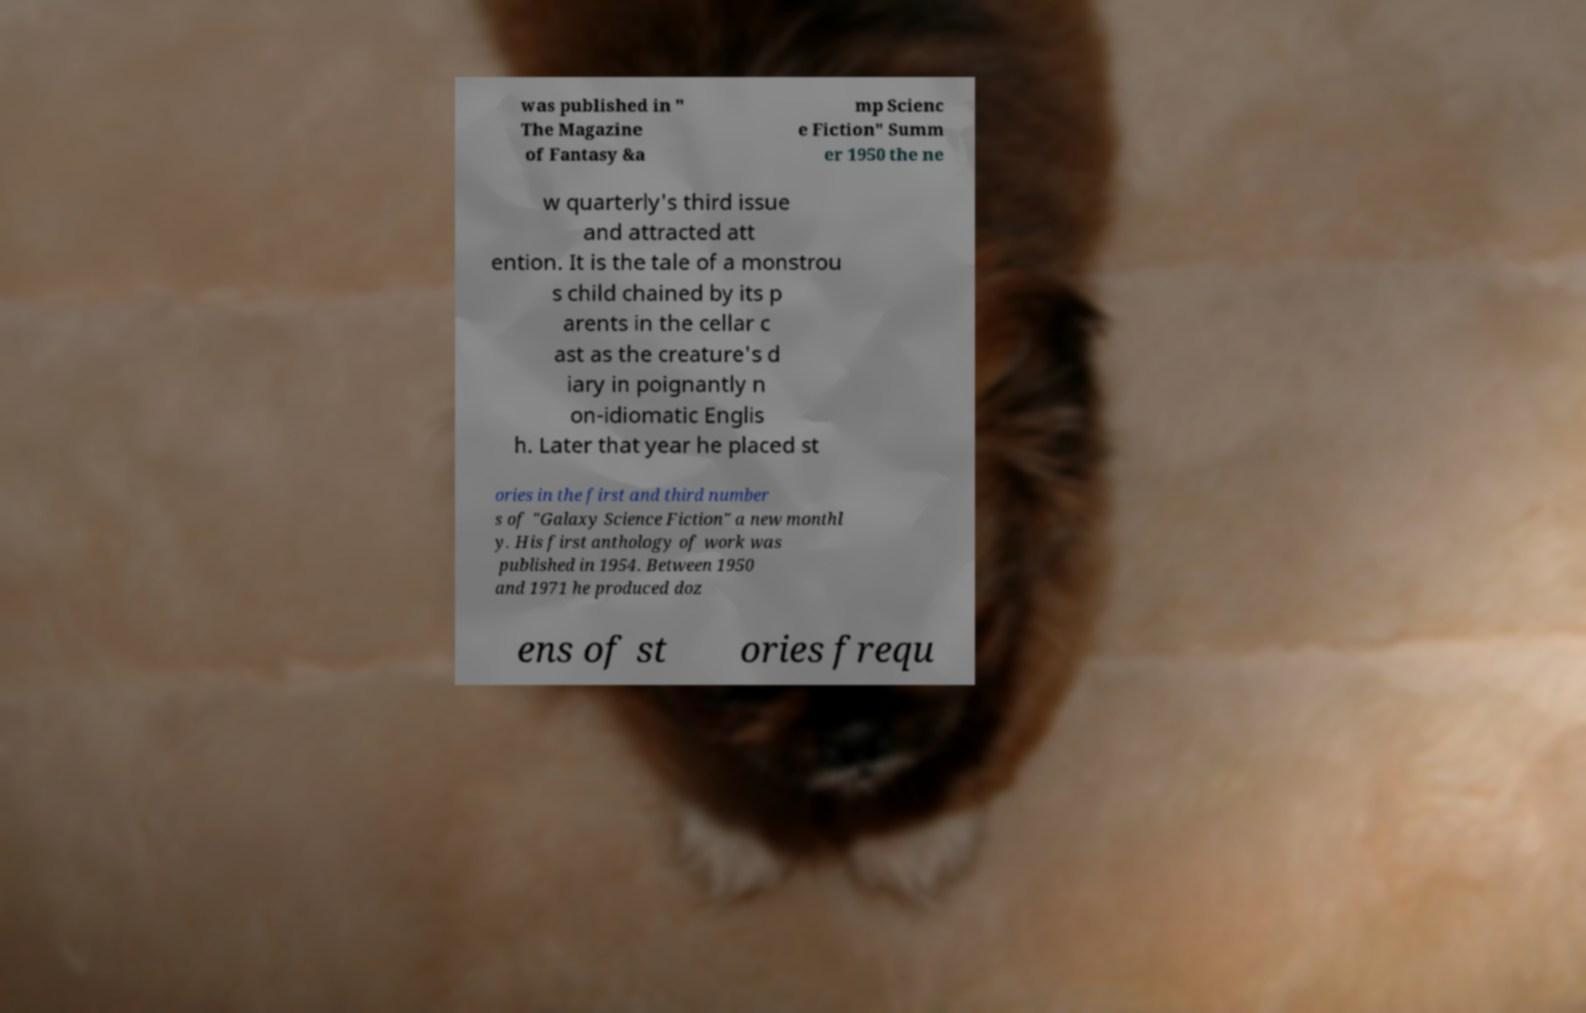Please read and relay the text visible in this image. What does it say? was published in " The Magazine of Fantasy &a mp Scienc e Fiction" Summ er 1950 the ne w quarterly's third issue and attracted att ention. It is the tale of a monstrou s child chained by its p arents in the cellar c ast as the creature's d iary in poignantly n on-idiomatic Englis h. Later that year he placed st ories in the first and third number s of "Galaxy Science Fiction" a new monthl y. His first anthology of work was published in 1954. Between 1950 and 1971 he produced doz ens of st ories frequ 